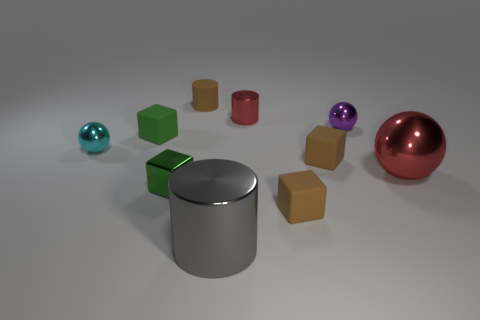Subtract all cylinders. How many objects are left? 7 Subtract 0 blue cylinders. How many objects are left? 10 Subtract all gray blocks. Subtract all balls. How many objects are left? 7 Add 2 tiny objects. How many tiny objects are left? 10 Add 3 red rubber cylinders. How many red rubber cylinders exist? 3 